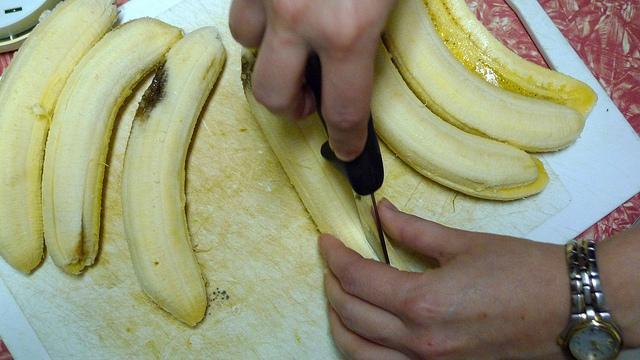How many bananas are bruised?
Give a very brief answer. 2. How many bananas are in the photo?
Give a very brief answer. 6. 